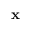<formula> <loc_0><loc_0><loc_500><loc_500>x</formula> 